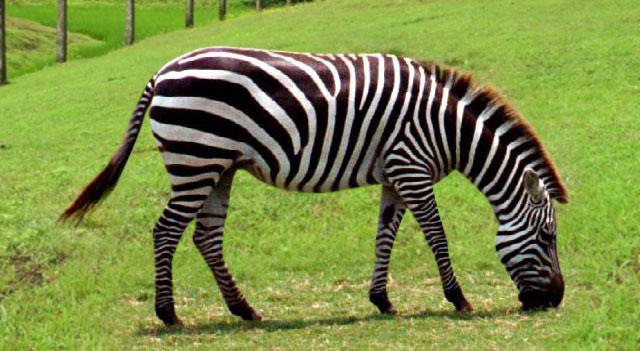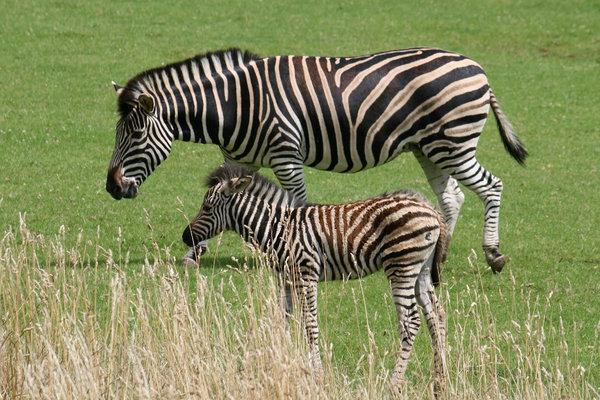The first image is the image on the left, the second image is the image on the right. Considering the images on both sides, is "The left image contains one rightward turned standing zebra in profile, with its head bent to the grass, and the right image includes an adult standing leftward-turned zebra with one back hoof raised." valid? Answer yes or no. Yes. The first image is the image on the left, the second image is the image on the right. For the images shown, is this caption "The right image contains two zebras." true? Answer yes or no. Yes. 